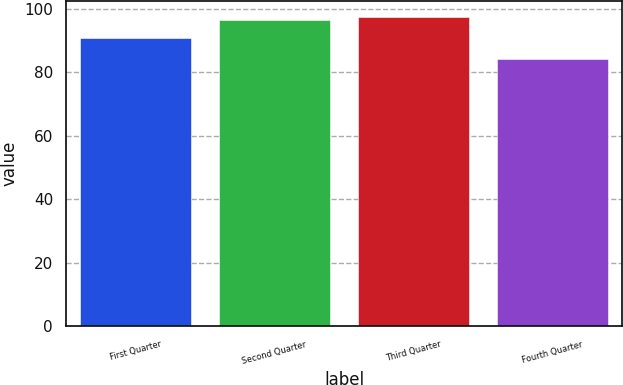<chart> <loc_0><loc_0><loc_500><loc_500><bar_chart><fcel>First Quarter<fcel>Second Quarter<fcel>Third Quarter<fcel>Fourth Quarter<nl><fcel>90.83<fcel>96.33<fcel>97.55<fcel>84.19<nl></chart> 